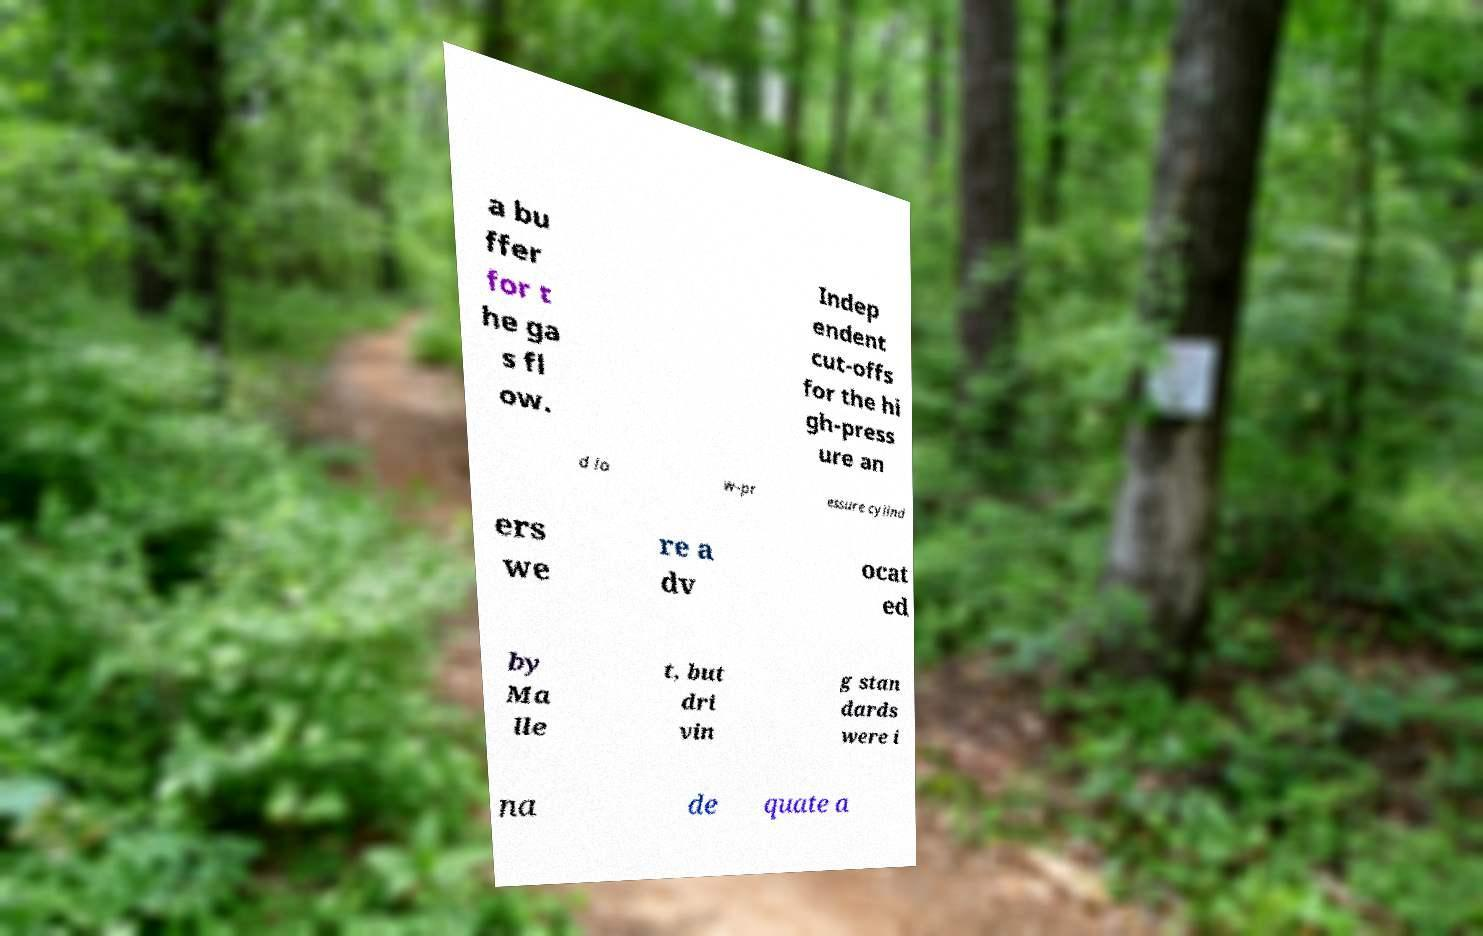Can you read and provide the text displayed in the image?This photo seems to have some interesting text. Can you extract and type it out for me? a bu ffer for t he ga s fl ow. Indep endent cut-offs for the hi gh-press ure an d lo w-pr essure cylind ers we re a dv ocat ed by Ma lle t, but dri vin g stan dards were i na de quate a 